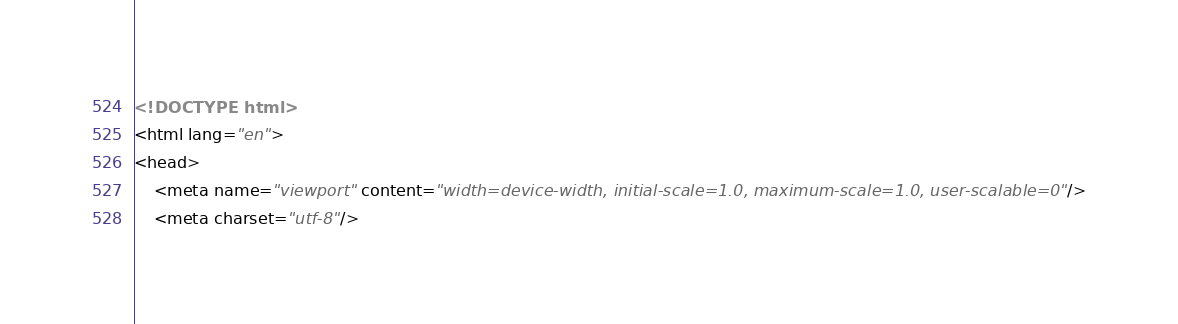<code> <loc_0><loc_0><loc_500><loc_500><_HTML_><!DOCTYPE html>
<html lang="en">
<head>
    <meta name="viewport" content="width=device-width, initial-scale=1.0, maximum-scale=1.0, user-scalable=0"/>
    <meta charset="utf-8"/></code> 